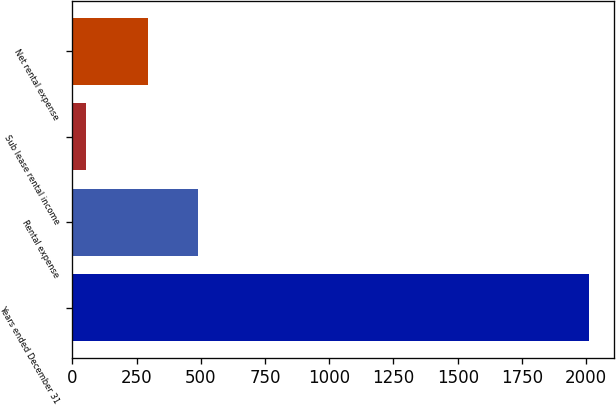<chart> <loc_0><loc_0><loc_500><loc_500><bar_chart><fcel>Years ended December 31<fcel>Rental expense<fcel>Sub lease rental income<fcel>Net rental expense<nl><fcel>2009<fcel>489.7<fcel>52<fcel>294<nl></chart> 